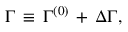Convert formula to latex. <formula><loc_0><loc_0><loc_500><loc_500>\Gamma \, \equiv \, { \Gamma } ^ { ( 0 ) } \, + \, \Delta \Gamma ,</formula> 